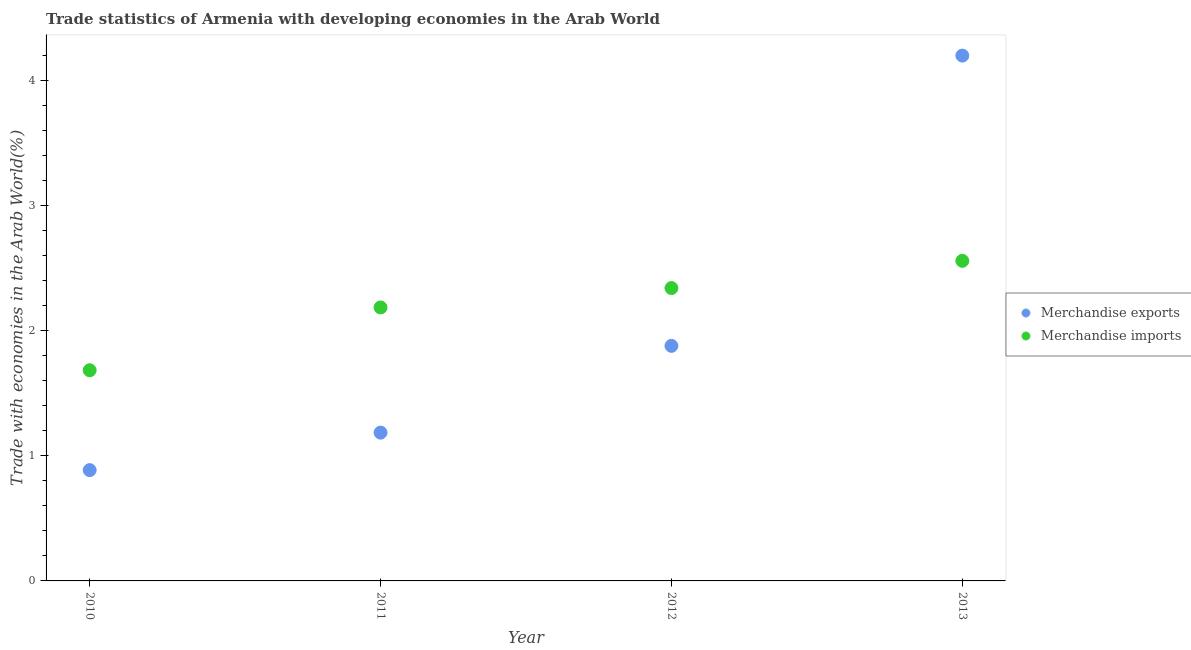Is the number of dotlines equal to the number of legend labels?
Give a very brief answer. Yes. What is the merchandise imports in 2013?
Your response must be concise. 2.56. Across all years, what is the maximum merchandise imports?
Your response must be concise. 2.56. Across all years, what is the minimum merchandise exports?
Provide a succinct answer. 0.89. In which year was the merchandise exports minimum?
Provide a succinct answer. 2010. What is the total merchandise exports in the graph?
Provide a succinct answer. 8.15. What is the difference between the merchandise imports in 2010 and that in 2012?
Make the answer very short. -0.66. What is the difference between the merchandise exports in 2011 and the merchandise imports in 2013?
Make the answer very short. -1.37. What is the average merchandise exports per year?
Make the answer very short. 2.04. In the year 2013, what is the difference between the merchandise exports and merchandise imports?
Your answer should be very brief. 1.64. What is the ratio of the merchandise imports in 2012 to that in 2013?
Provide a succinct answer. 0.91. What is the difference between the highest and the second highest merchandise exports?
Your response must be concise. 2.32. What is the difference between the highest and the lowest merchandise exports?
Provide a succinct answer. 3.31. In how many years, is the merchandise imports greater than the average merchandise imports taken over all years?
Make the answer very short. 2. Does the merchandise exports monotonically increase over the years?
Provide a short and direct response. Yes. Does the graph contain grids?
Provide a succinct answer. No. Where does the legend appear in the graph?
Keep it short and to the point. Center right. What is the title of the graph?
Your answer should be very brief. Trade statistics of Armenia with developing economies in the Arab World. What is the label or title of the X-axis?
Ensure brevity in your answer.  Year. What is the label or title of the Y-axis?
Offer a very short reply. Trade with economies in the Arab World(%). What is the Trade with economies in the Arab World(%) in Merchandise exports in 2010?
Offer a terse response. 0.89. What is the Trade with economies in the Arab World(%) in Merchandise imports in 2010?
Provide a succinct answer. 1.68. What is the Trade with economies in the Arab World(%) of Merchandise exports in 2011?
Your answer should be compact. 1.19. What is the Trade with economies in the Arab World(%) in Merchandise imports in 2011?
Your answer should be very brief. 2.19. What is the Trade with economies in the Arab World(%) in Merchandise exports in 2012?
Offer a very short reply. 1.88. What is the Trade with economies in the Arab World(%) of Merchandise imports in 2012?
Your answer should be compact. 2.34. What is the Trade with economies in the Arab World(%) in Merchandise exports in 2013?
Ensure brevity in your answer.  4.2. What is the Trade with economies in the Arab World(%) of Merchandise imports in 2013?
Offer a very short reply. 2.56. Across all years, what is the maximum Trade with economies in the Arab World(%) in Merchandise exports?
Give a very brief answer. 4.2. Across all years, what is the maximum Trade with economies in the Arab World(%) of Merchandise imports?
Offer a terse response. 2.56. Across all years, what is the minimum Trade with economies in the Arab World(%) in Merchandise exports?
Your response must be concise. 0.89. Across all years, what is the minimum Trade with economies in the Arab World(%) of Merchandise imports?
Ensure brevity in your answer.  1.68. What is the total Trade with economies in the Arab World(%) of Merchandise exports in the graph?
Keep it short and to the point. 8.15. What is the total Trade with economies in the Arab World(%) of Merchandise imports in the graph?
Give a very brief answer. 8.77. What is the difference between the Trade with economies in the Arab World(%) in Merchandise exports in 2010 and that in 2011?
Offer a very short reply. -0.3. What is the difference between the Trade with economies in the Arab World(%) of Merchandise imports in 2010 and that in 2011?
Keep it short and to the point. -0.5. What is the difference between the Trade with economies in the Arab World(%) of Merchandise exports in 2010 and that in 2012?
Offer a terse response. -0.99. What is the difference between the Trade with economies in the Arab World(%) in Merchandise imports in 2010 and that in 2012?
Ensure brevity in your answer.  -0.66. What is the difference between the Trade with economies in the Arab World(%) of Merchandise exports in 2010 and that in 2013?
Offer a terse response. -3.31. What is the difference between the Trade with economies in the Arab World(%) of Merchandise imports in 2010 and that in 2013?
Give a very brief answer. -0.87. What is the difference between the Trade with economies in the Arab World(%) in Merchandise exports in 2011 and that in 2012?
Make the answer very short. -0.69. What is the difference between the Trade with economies in the Arab World(%) in Merchandise imports in 2011 and that in 2012?
Your answer should be compact. -0.15. What is the difference between the Trade with economies in the Arab World(%) in Merchandise exports in 2011 and that in 2013?
Make the answer very short. -3.01. What is the difference between the Trade with economies in the Arab World(%) in Merchandise imports in 2011 and that in 2013?
Ensure brevity in your answer.  -0.37. What is the difference between the Trade with economies in the Arab World(%) in Merchandise exports in 2012 and that in 2013?
Provide a succinct answer. -2.32. What is the difference between the Trade with economies in the Arab World(%) of Merchandise imports in 2012 and that in 2013?
Your answer should be compact. -0.22. What is the difference between the Trade with economies in the Arab World(%) in Merchandise exports in 2010 and the Trade with economies in the Arab World(%) in Merchandise imports in 2011?
Your answer should be very brief. -1.3. What is the difference between the Trade with economies in the Arab World(%) of Merchandise exports in 2010 and the Trade with economies in the Arab World(%) of Merchandise imports in 2012?
Offer a terse response. -1.46. What is the difference between the Trade with economies in the Arab World(%) in Merchandise exports in 2010 and the Trade with economies in the Arab World(%) in Merchandise imports in 2013?
Offer a very short reply. -1.67. What is the difference between the Trade with economies in the Arab World(%) of Merchandise exports in 2011 and the Trade with economies in the Arab World(%) of Merchandise imports in 2012?
Your answer should be compact. -1.16. What is the difference between the Trade with economies in the Arab World(%) of Merchandise exports in 2011 and the Trade with economies in the Arab World(%) of Merchandise imports in 2013?
Ensure brevity in your answer.  -1.37. What is the difference between the Trade with economies in the Arab World(%) of Merchandise exports in 2012 and the Trade with economies in the Arab World(%) of Merchandise imports in 2013?
Ensure brevity in your answer.  -0.68. What is the average Trade with economies in the Arab World(%) of Merchandise exports per year?
Your answer should be compact. 2.04. What is the average Trade with economies in the Arab World(%) of Merchandise imports per year?
Provide a short and direct response. 2.19. In the year 2010, what is the difference between the Trade with economies in the Arab World(%) of Merchandise exports and Trade with economies in the Arab World(%) of Merchandise imports?
Your response must be concise. -0.8. In the year 2011, what is the difference between the Trade with economies in the Arab World(%) of Merchandise exports and Trade with economies in the Arab World(%) of Merchandise imports?
Make the answer very short. -1. In the year 2012, what is the difference between the Trade with economies in the Arab World(%) in Merchandise exports and Trade with economies in the Arab World(%) in Merchandise imports?
Give a very brief answer. -0.46. In the year 2013, what is the difference between the Trade with economies in the Arab World(%) of Merchandise exports and Trade with economies in the Arab World(%) of Merchandise imports?
Your answer should be very brief. 1.64. What is the ratio of the Trade with economies in the Arab World(%) in Merchandise exports in 2010 to that in 2011?
Ensure brevity in your answer.  0.75. What is the ratio of the Trade with economies in the Arab World(%) in Merchandise imports in 2010 to that in 2011?
Provide a short and direct response. 0.77. What is the ratio of the Trade with economies in the Arab World(%) in Merchandise exports in 2010 to that in 2012?
Give a very brief answer. 0.47. What is the ratio of the Trade with economies in the Arab World(%) of Merchandise imports in 2010 to that in 2012?
Ensure brevity in your answer.  0.72. What is the ratio of the Trade with economies in the Arab World(%) of Merchandise exports in 2010 to that in 2013?
Your answer should be compact. 0.21. What is the ratio of the Trade with economies in the Arab World(%) in Merchandise imports in 2010 to that in 2013?
Give a very brief answer. 0.66. What is the ratio of the Trade with economies in the Arab World(%) in Merchandise exports in 2011 to that in 2012?
Keep it short and to the point. 0.63. What is the ratio of the Trade with economies in the Arab World(%) of Merchandise imports in 2011 to that in 2012?
Keep it short and to the point. 0.93. What is the ratio of the Trade with economies in the Arab World(%) of Merchandise exports in 2011 to that in 2013?
Ensure brevity in your answer.  0.28. What is the ratio of the Trade with economies in the Arab World(%) of Merchandise imports in 2011 to that in 2013?
Offer a very short reply. 0.85. What is the ratio of the Trade with economies in the Arab World(%) of Merchandise exports in 2012 to that in 2013?
Make the answer very short. 0.45. What is the ratio of the Trade with economies in the Arab World(%) in Merchandise imports in 2012 to that in 2013?
Ensure brevity in your answer.  0.91. What is the difference between the highest and the second highest Trade with economies in the Arab World(%) of Merchandise exports?
Ensure brevity in your answer.  2.32. What is the difference between the highest and the second highest Trade with economies in the Arab World(%) of Merchandise imports?
Keep it short and to the point. 0.22. What is the difference between the highest and the lowest Trade with economies in the Arab World(%) of Merchandise exports?
Keep it short and to the point. 3.31. What is the difference between the highest and the lowest Trade with economies in the Arab World(%) of Merchandise imports?
Your response must be concise. 0.87. 